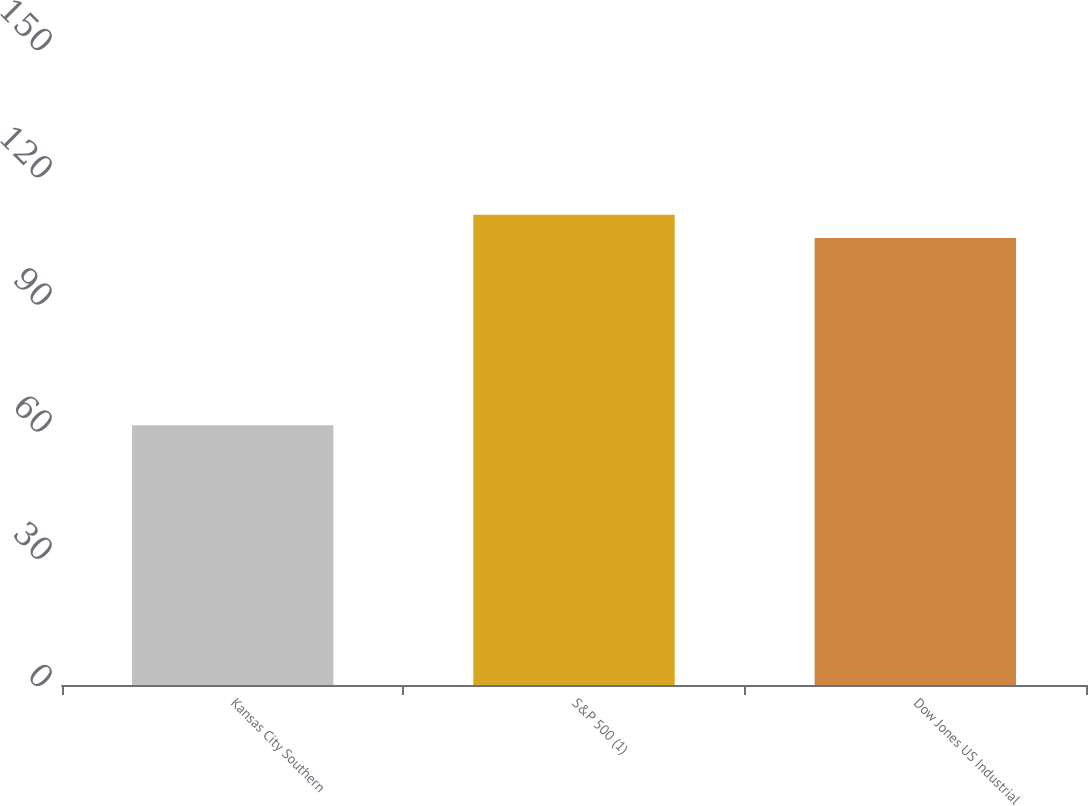<chart> <loc_0><loc_0><loc_500><loc_500><bar_chart><fcel>Kansas City Southern<fcel>S&P 500 (1)<fcel>Dow Jones US Industrial<nl><fcel>71.28<fcel>129.05<fcel>122.67<nl></chart> 